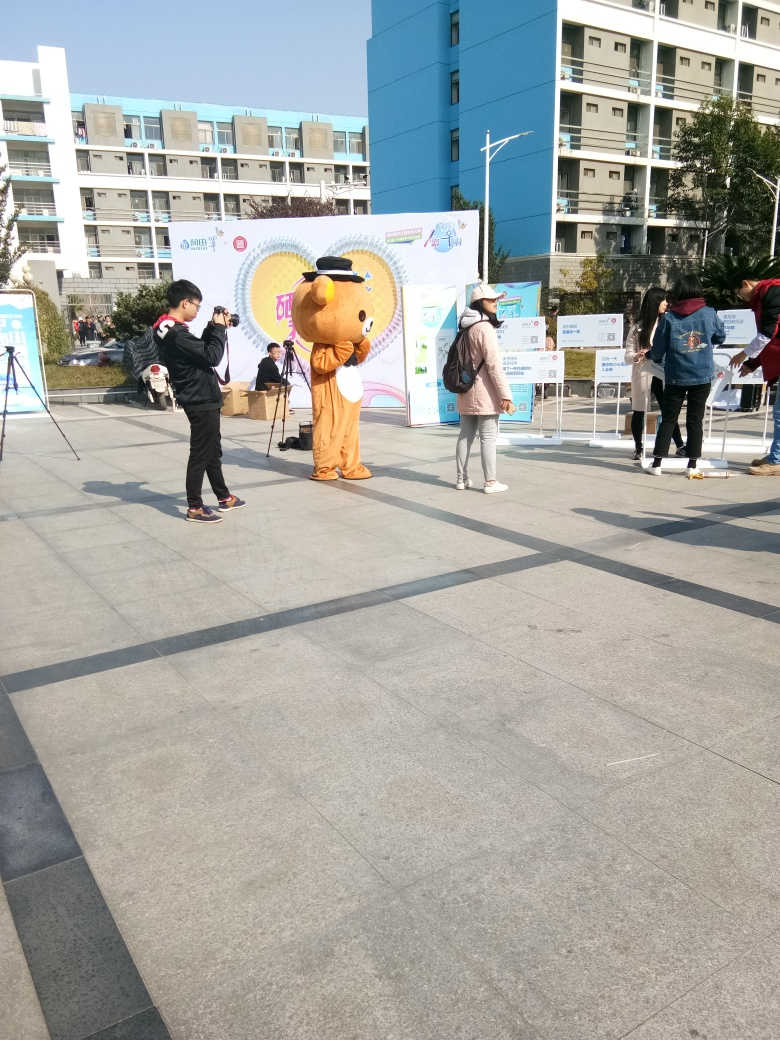What event might be taking place here? The presence of a person in a mascot costume and a camera tripod suggests that this could be a promotional event or a community gathering, possibly related to a local celebration or marketing campaign. 